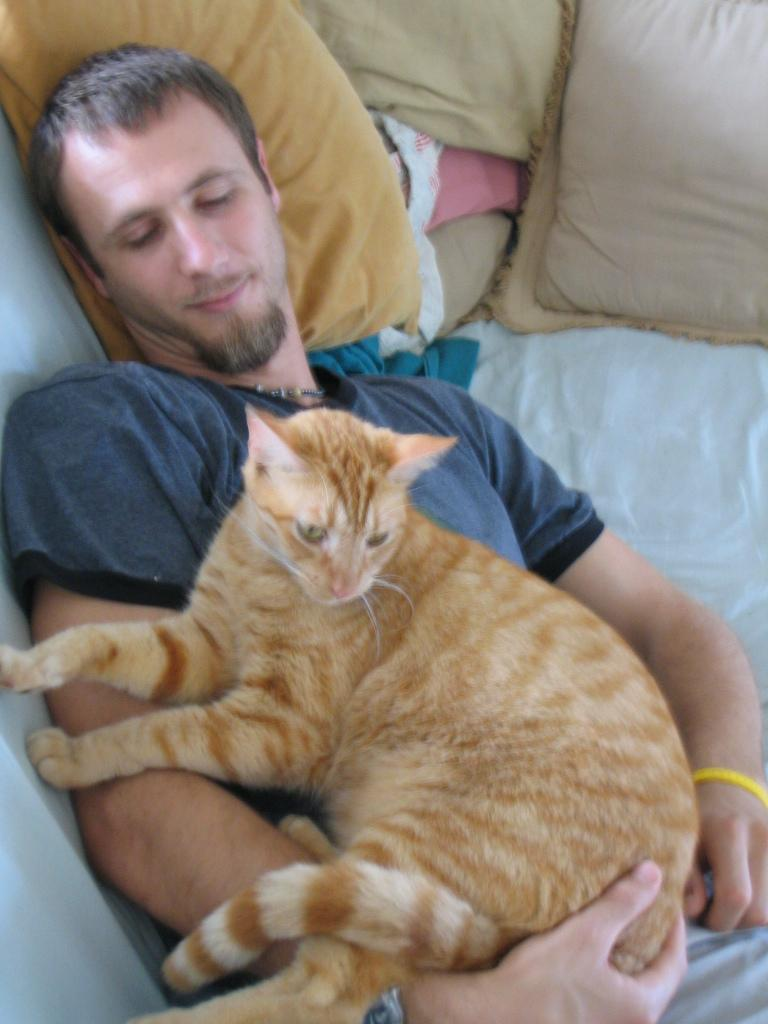Who is present in the image? There is a man in the image. What is the man doing in the image? The man is laying on the bed. What can be seen on the bed besides the man? There are pillows in the image. Are there any animals present in the image? Yes, there is a cat in the image. What type of airplane is visible in the image? There is no airplane present in the image; it features a man laying on a bed with pillows and a cat. Can you describe the line that the man is drawing on the bed? There is no line or drawing activity present in the image; the man is simply laying on the bed. 